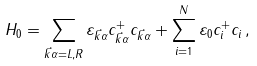<formula> <loc_0><loc_0><loc_500><loc_500>H _ { 0 } = \sum _ { \vec { k } \alpha = L , R } \varepsilon _ { \vec { k } \alpha } c ^ { + } _ { \vec { k } \alpha } c _ { \vec { k } \alpha } + \sum ^ { N } _ { i = 1 } \varepsilon _ { 0 } c ^ { + } _ { i } c _ { i } \, ,</formula> 